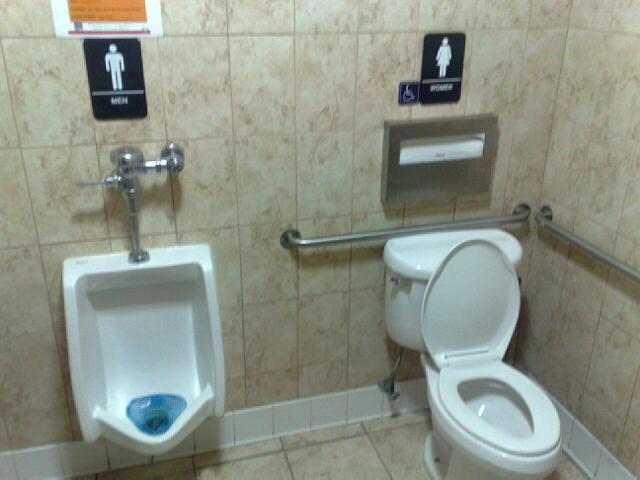How many toilets are in the photo?
Give a very brief answer. 2. How many train cars are under the poles?
Give a very brief answer. 0. 